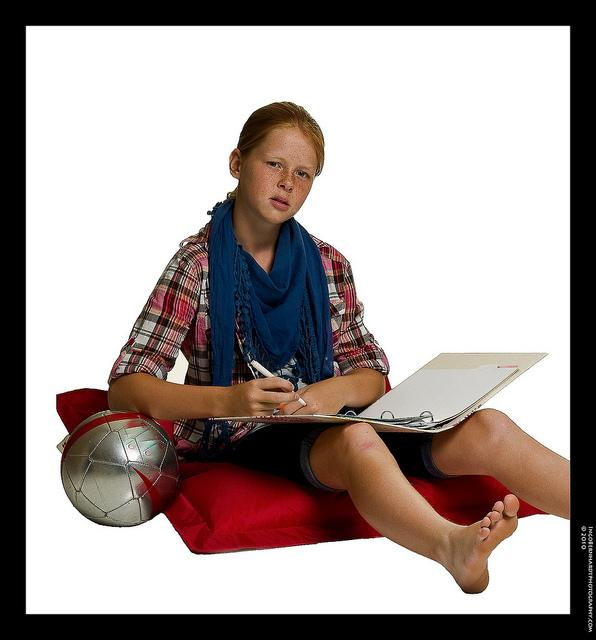What happened to the background? removed 